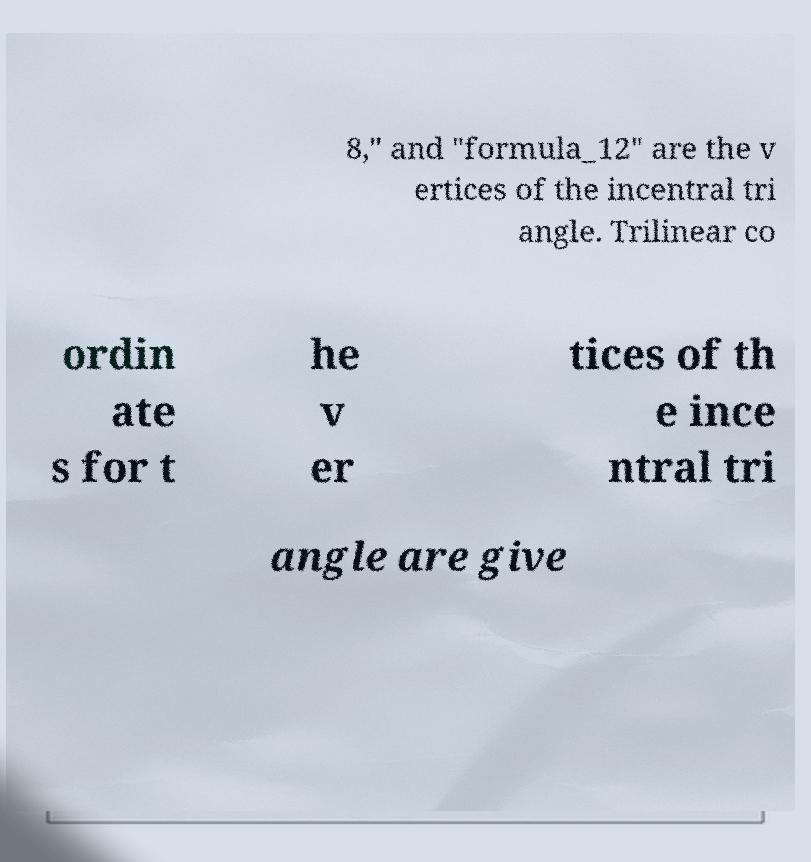Please identify and transcribe the text found in this image. 8," and "formula_12" are the v ertices of the incentral tri angle. Trilinear co ordin ate s for t he v er tices of th e ince ntral tri angle are give 